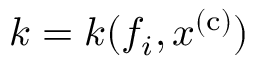Convert formula to latex. <formula><loc_0><loc_0><loc_500><loc_500>k = k ( f _ { i } , x ^ { ( c ) } )</formula> 